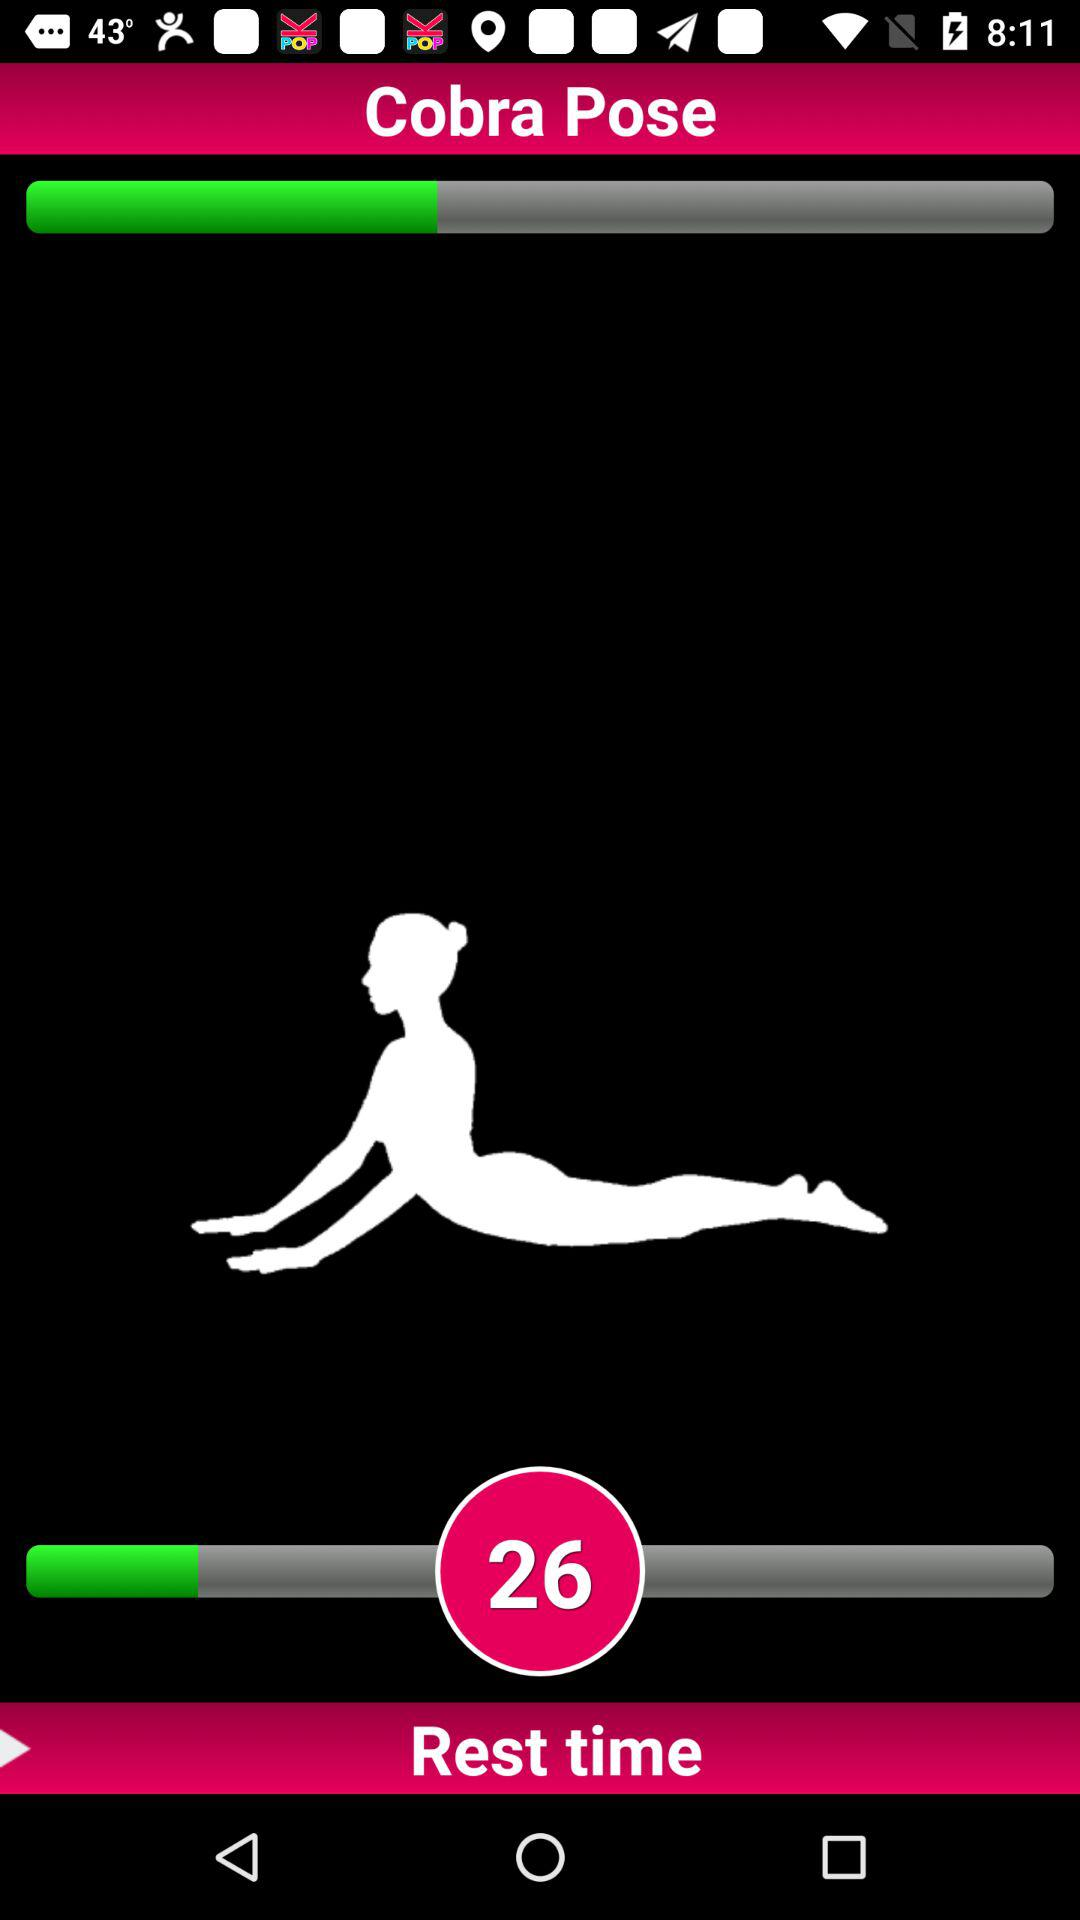What is the set level for "Cobra Pose"? The set level is 26. 